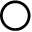Convert formula to latex. <formula><loc_0><loc_0><loc_500><loc_500>\bigcirc</formula> 